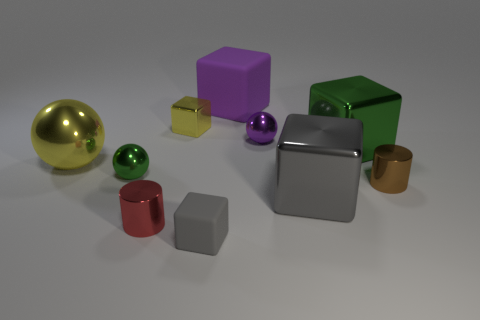Subtract all shiny cubes. How many cubes are left? 2 Subtract all green cylinders. How many gray blocks are left? 2 Subtract all purple spheres. How many spheres are left? 2 Subtract all cylinders. How many objects are left? 8 Subtract 2 cylinders. How many cylinders are left? 0 Subtract all blue spheres. Subtract all blue cylinders. How many spheres are left? 3 Subtract all blue metal cylinders. Subtract all gray rubber objects. How many objects are left? 9 Add 8 large green objects. How many large green objects are left? 9 Add 4 small metal cylinders. How many small metal cylinders exist? 6 Subtract 0 purple cylinders. How many objects are left? 10 